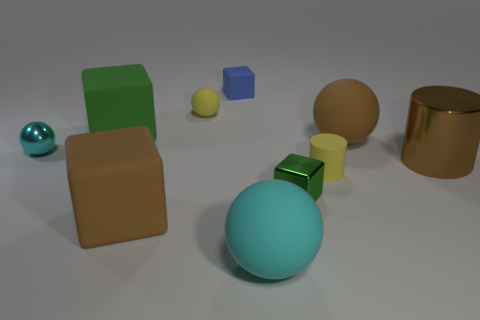What shape is the small blue object on the left side of the large ball that is in front of the tiny cyan sphere?
Your answer should be very brief. Cube. Do the cyan sphere that is left of the blue rubber cube and the brown matte ball have the same size?
Make the answer very short. No. What is the size of the matte ball that is behind the cyan metallic ball and left of the tiny green metallic object?
Ensure brevity in your answer.  Small. How many blue rubber blocks have the same size as the green rubber cube?
Keep it short and to the point. 0. There is a large brown matte object that is to the left of the small yellow ball; what number of blue things are in front of it?
Give a very brief answer. 0. There is a cylinder left of the brown shiny cylinder; is its color the same as the small metal sphere?
Provide a short and direct response. No. There is a rubber ball in front of the yellow object that is to the right of the small green thing; is there a small green object that is to the right of it?
Your answer should be compact. Yes. What is the shape of the metal thing that is both to the left of the large cylinder and on the right side of the green rubber block?
Your answer should be compact. Cube. Are there any big metal cylinders that have the same color as the small matte ball?
Offer a very short reply. No. The tiny metallic thing that is behind the yellow thing in front of the big green block is what color?
Provide a short and direct response. Cyan. 